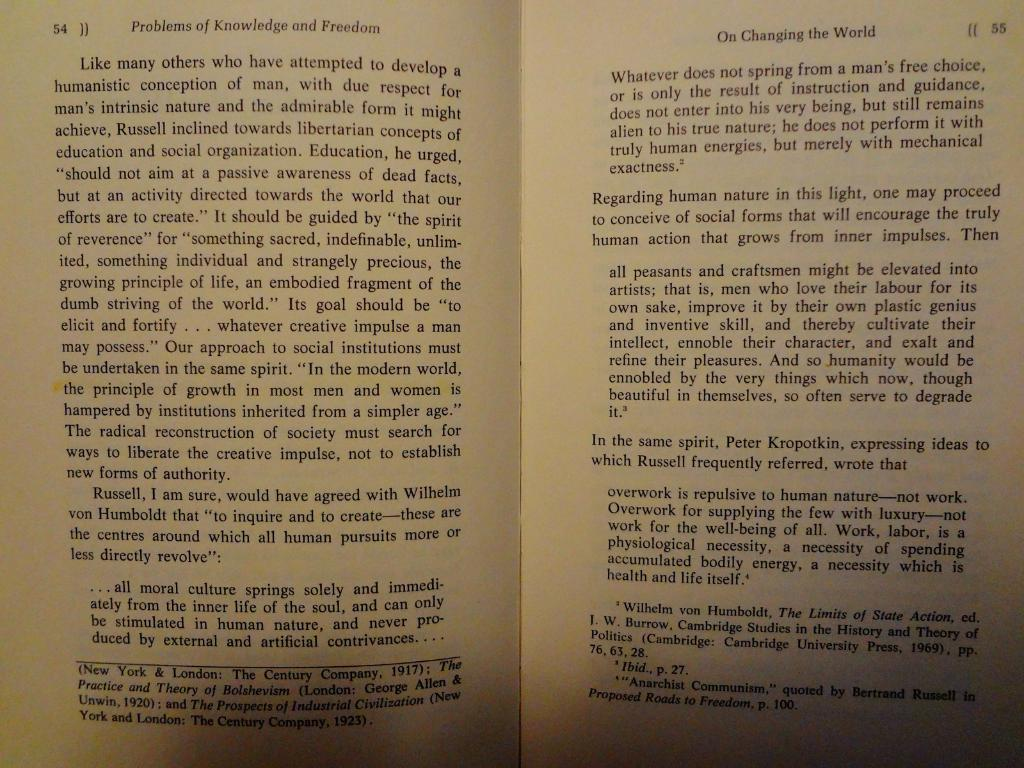<image>
Render a clear and concise summary of the photo. Two pages from a book on changing the world. 